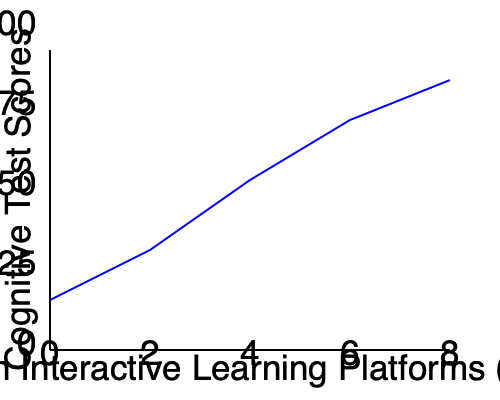Based on the line graph showing the correlation between time spent on interactive learning platforms and cognitive test scores, what can be inferred about the relationship between these two variables? Additionally, calculate the approximate rate of change in cognitive test scores per hour of platform use between 0 and 8 hours per week. To answer this question, we need to analyze the graph and perform some calculations:

1. Relationship inference:
   - The line graph shows an upward trend from left to right.
   - As the time spent on interactive learning platforms increases, cognitive test scores also increase.
   - This indicates a positive correlation between the two variables.

2. Rate of change calculation:
   - We need to calculate the change in cognitive test scores divided by the change in time spent.
   - At 0 hours/week, the cognitive test score is approximately 0.
   - At 8 hours/week, the cognitive test score is approximately 85.
   - Change in cognitive test scores: 85 - 0 = 85
   - Change in time spent: 8 - 0 = 8 hours

   Rate of change = $\frac{\text{Change in cognitive test scores}}{\text{Change in time spent}}$
                  = $\frac{85}{8}$ = 10.625 points per hour

Therefore, we can infer a positive correlation between time spent on interactive learning platforms and cognitive test scores, with an approximate rate of change of 10.625 points per hour of platform use.
Answer: Positive correlation; 10.625 points/hour 